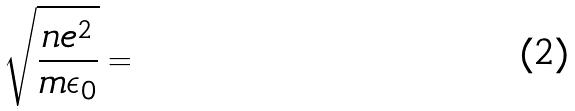Convert formula to latex. <formula><loc_0><loc_0><loc_500><loc_500>\sqrt { \frac { n e ^ { 2 } } { m \epsilon _ { 0 } } } =</formula> 